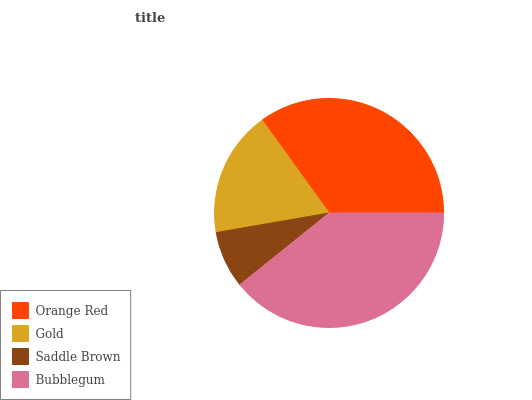Is Saddle Brown the minimum?
Answer yes or no. Yes. Is Bubblegum the maximum?
Answer yes or no. Yes. Is Gold the minimum?
Answer yes or no. No. Is Gold the maximum?
Answer yes or no. No. Is Orange Red greater than Gold?
Answer yes or no. Yes. Is Gold less than Orange Red?
Answer yes or no. Yes. Is Gold greater than Orange Red?
Answer yes or no. No. Is Orange Red less than Gold?
Answer yes or no. No. Is Orange Red the high median?
Answer yes or no. Yes. Is Gold the low median?
Answer yes or no. Yes. Is Bubblegum the high median?
Answer yes or no. No. Is Orange Red the low median?
Answer yes or no. No. 